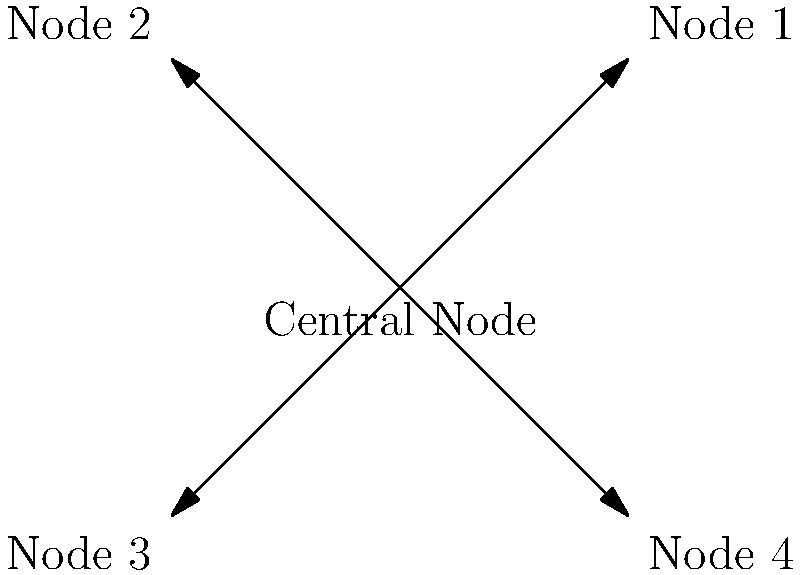As a machine learning engineer mentoring a child in AI model development, you're explaining network topologies. Which network topology is represented in the diagram, given that it features a central node connecting to all other nodes directly, and is commonly used in local area networks (LANs) for its simplicity and ease of management? To identify the correct network topology, let's analyze the key characteristics of the diagram and compare them to known network topologies:

1. Central node: The diagram shows a central node connected to all other nodes.
2. Direct connections: Each peripheral node is directly connected to the central node.
3. No connections between peripheral nodes: The outer nodes are not connected to each other.

These characteristics are typical of a Star topology:

1. Star topology has a central node (often a switch or hub) that acts as a central point of connection.
2. All other nodes in the network connect directly to this central node.
3. There are no direct connections between the peripheral nodes.

Additional information supporting this conclusion:
- Star topologies are indeed commonly used in LANs.
- They are known for their simplicity and ease of management, as mentioned in the question.
- Adding or removing nodes is straightforward in this topology, which aligns with its ease of management.

Therefore, based on the diagram and the given information, the network topology represented is a Star topology.
Answer: Star topology 